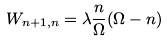Convert formula to latex. <formula><loc_0><loc_0><loc_500><loc_500>W _ { n + 1 , n } = \lambda \frac { n } { \Omega } ( \Omega - n )</formula> 